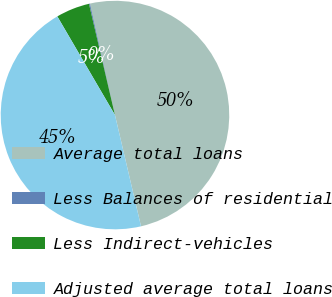Convert chart to OTSL. <chart><loc_0><loc_0><loc_500><loc_500><pie_chart><fcel>Average total loans<fcel>Less Balances of residential<fcel>Less Indirect-vehicles<fcel>Adjusted average total loans<nl><fcel>49.85%<fcel>0.15%<fcel>4.76%<fcel>45.24%<nl></chart> 